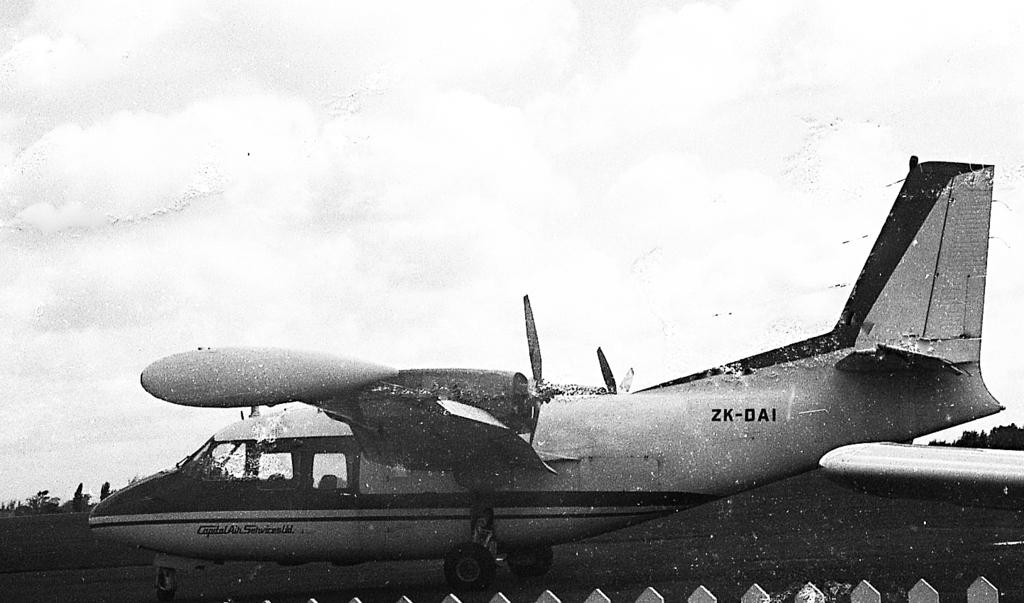<image>
Present a compact description of the photo's key features. A small aircraft written ZK-DAI looks like it is bad shape 